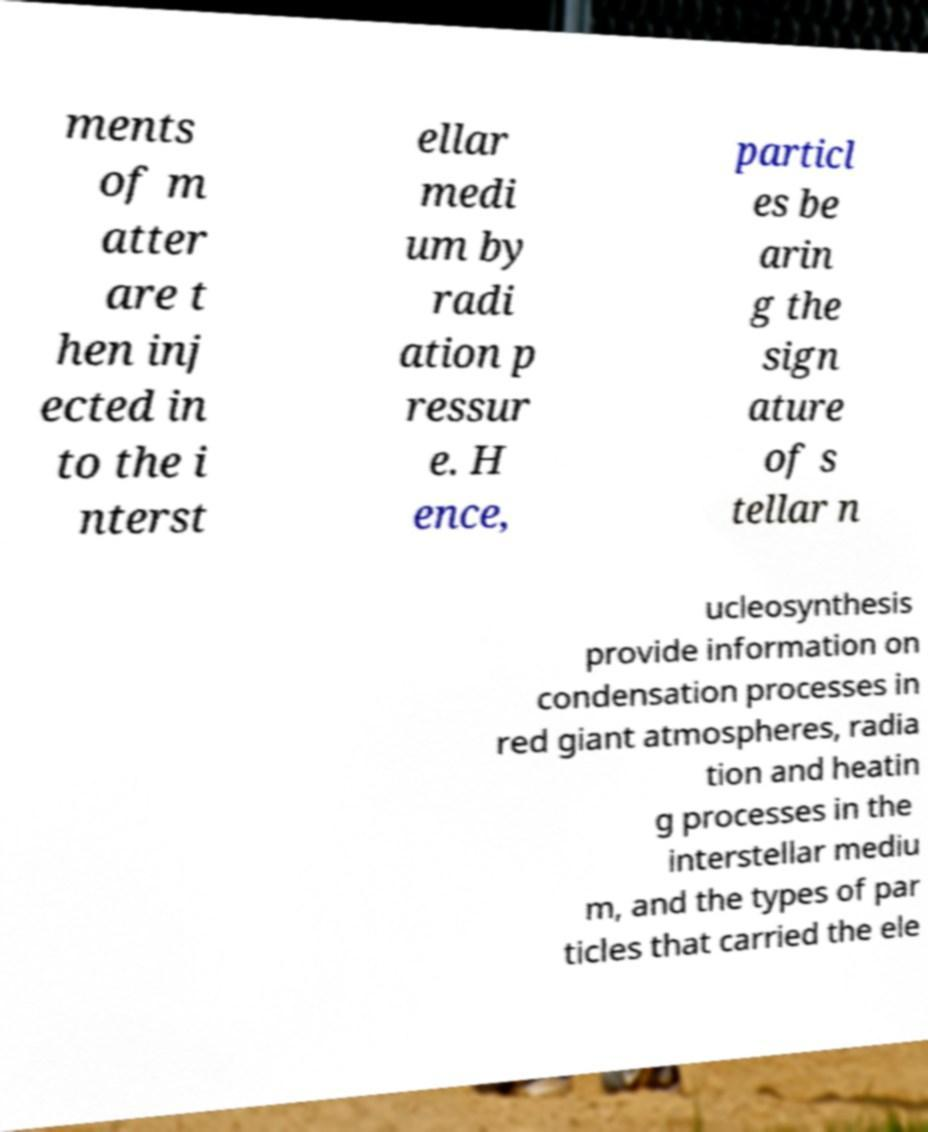Please identify and transcribe the text found in this image. ments of m atter are t hen inj ected in to the i nterst ellar medi um by radi ation p ressur e. H ence, particl es be arin g the sign ature of s tellar n ucleosynthesis provide information on condensation processes in red giant atmospheres, radia tion and heatin g processes in the interstellar mediu m, and the types of par ticles that carried the ele 